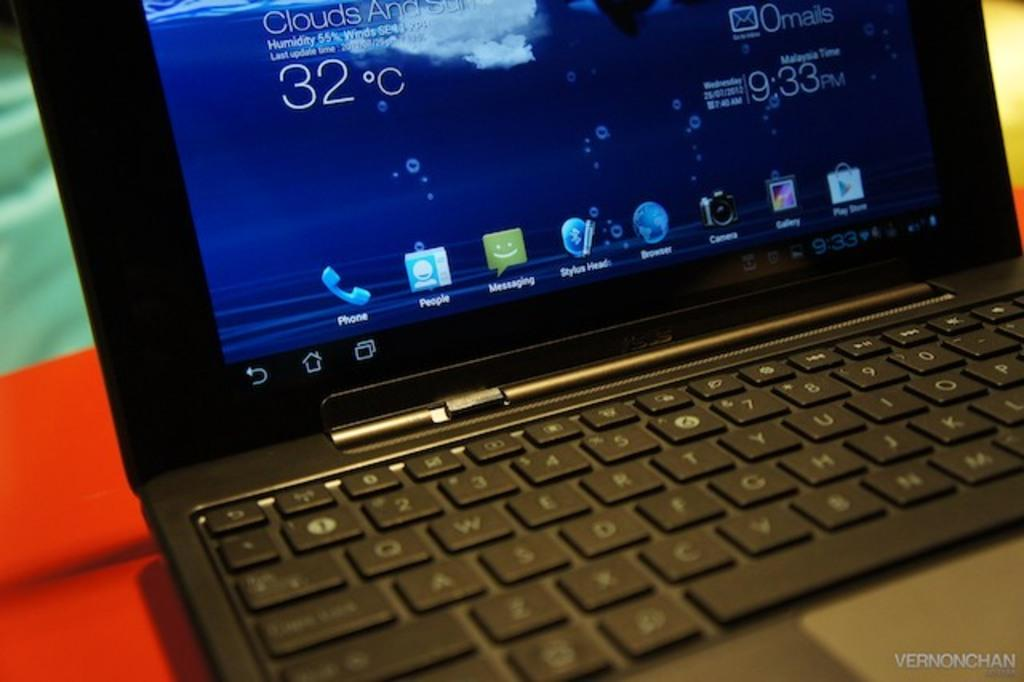<image>
Render a clear and concise summary of the photo. A laptop with the screen on showing it is 32 degrees c. 